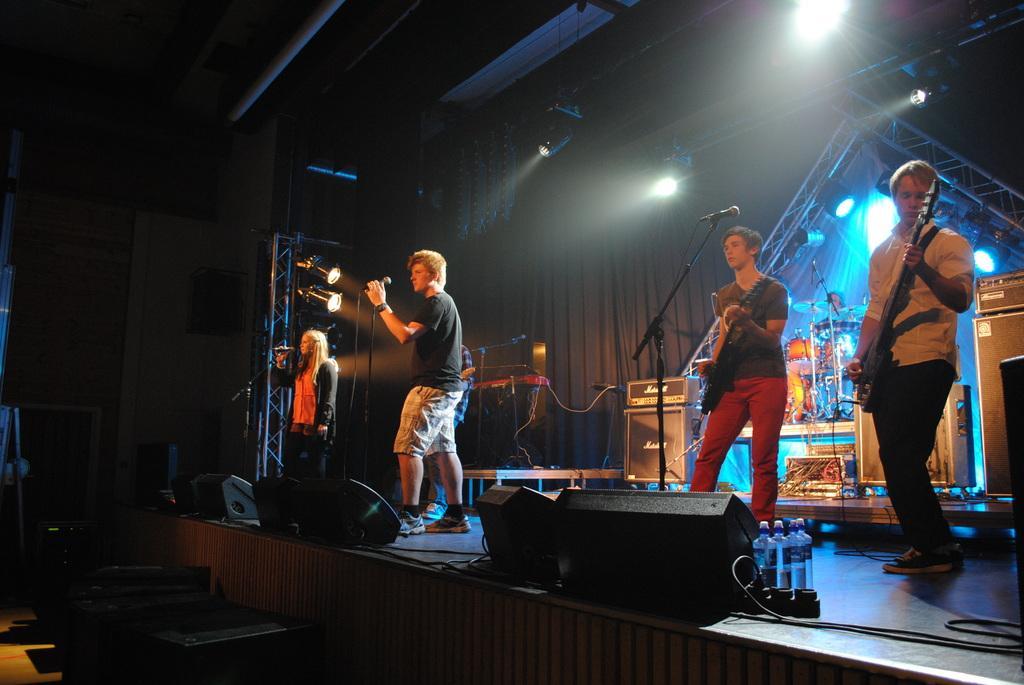Can you describe this image briefly? The picture is taken on the stage where at the right corner one person is playing guitar and in the middle one person is playing guitar, behind him there are drums, speakers and microphones and at the left corner of the picture on the stage one woman is singing, behind her another man is singing in front of microphone and there are water bottles, speakers on the stage. 